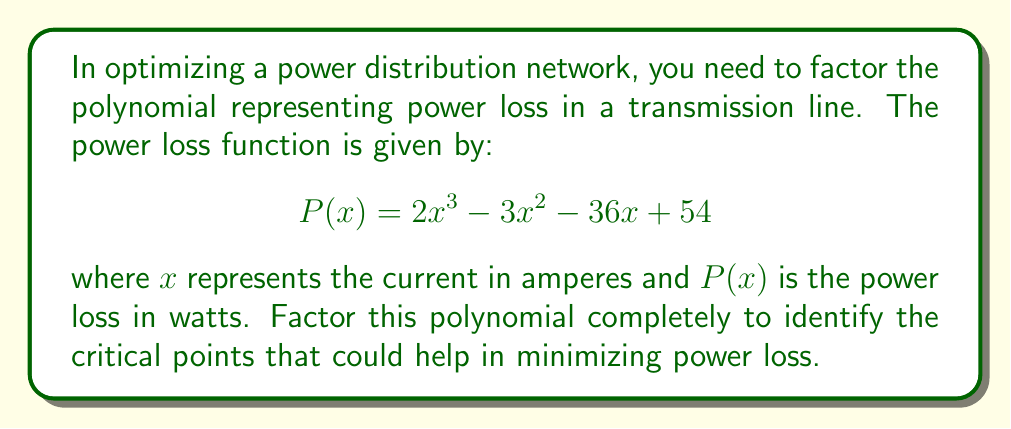Give your solution to this math problem. To factor this polynomial, we'll follow these steps:

1) First, let's check if there's a common factor:
   There's no common factor for all terms.

2) Next, we'll try to guess a rational root. Using the rational root theorem, potential roots are factors of the constant term (54): ±1, ±2, ±3, ±6, ±9, ±18, ±27, ±54.

3) Testing these values, we find that $x = 3$ is a root.

4) Divide the polynomial by $(x - 3)$:

   $$\frac{2x^3 - 3x^2 - 36x + 54}{x - 3} = 2x^2 + 3x - 18$$

5) Now we have: $P(x) = (x - 3)(2x^2 + 3x - 18)$

6) Let's factor the quadratic term $2x^2 + 3x - 18$:
   
   a) $ac = 2(-18) = -36$
   b) We need two numbers that multiply to -36 and add to 3
   c) These numbers are 9 and -6

7) Rewrite the quadratic as: $2x^2 + 9x - 6x - 18$

8) Factor by grouping:
   $2x(x + \frac{9}{2}) - 6(x + 3)$
   $(2x - 6)(x + \frac{9}{2})$
   $2(x - 3)(x + \frac{9}{2})$

9) Combine this with our earlier factor:

   $$P(x) = (x - 3)(x - 3)(2x + 9)$$
   $$P(x) = (x - 3)^2(2x + 9)$$

This factored form reveals the critical points of the power loss function: $x = 3$ (double root) and $x = -\frac{9}{2}$.
Answer: $P(x) = (x - 3)^2(2x + 9)$ 